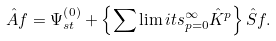<formula> <loc_0><loc_0><loc_500><loc_500>\hat { A } f = \Psi _ { s t } ^ { \left ( 0 \right ) } + \left \{ \sum \lim i t s _ { p = 0 } ^ { \infty } \hat { K } ^ { p } \right \} \hat { S } f .</formula> 